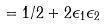<formula> <loc_0><loc_0><loc_500><loc_500>= 1 / 2 + 2 \epsilon _ { 1 } \epsilon _ { 2 }</formula> 